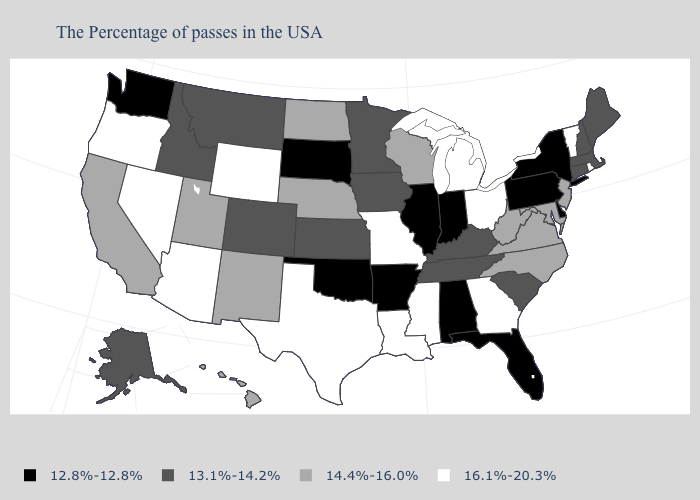Which states hav the highest value in the West?
Give a very brief answer. Wyoming, Arizona, Nevada, Oregon. Does the first symbol in the legend represent the smallest category?
Be succinct. Yes. Among the states that border Utah , does Nevada have the highest value?
Write a very short answer. Yes. Among the states that border Massachusetts , does Rhode Island have the highest value?
Concise answer only. Yes. What is the value of Kansas?
Keep it brief. 13.1%-14.2%. What is the highest value in the West ?
Give a very brief answer. 16.1%-20.3%. Which states have the highest value in the USA?
Keep it brief. Rhode Island, Vermont, Ohio, Georgia, Michigan, Mississippi, Louisiana, Missouri, Texas, Wyoming, Arizona, Nevada, Oregon. Which states have the lowest value in the MidWest?
Quick response, please. Indiana, Illinois, South Dakota. Name the states that have a value in the range 16.1%-20.3%?
Be succinct. Rhode Island, Vermont, Ohio, Georgia, Michigan, Mississippi, Louisiana, Missouri, Texas, Wyoming, Arizona, Nevada, Oregon. Does Montana have the lowest value in the USA?
Answer briefly. No. What is the value of New Jersey?
Write a very short answer. 14.4%-16.0%. Does Ohio have the highest value in the MidWest?
Write a very short answer. Yes. What is the value of Maine?
Give a very brief answer. 13.1%-14.2%. Name the states that have a value in the range 16.1%-20.3%?
Keep it brief. Rhode Island, Vermont, Ohio, Georgia, Michigan, Mississippi, Louisiana, Missouri, Texas, Wyoming, Arizona, Nevada, Oregon. Among the states that border Washington , does Idaho have the highest value?
Keep it brief. No. 